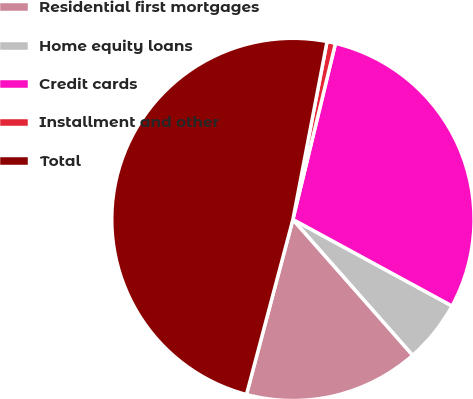<chart> <loc_0><loc_0><loc_500><loc_500><pie_chart><fcel>Residential first mortgages<fcel>Home equity loans<fcel>Credit cards<fcel>Installment and other<fcel>Total<nl><fcel>15.63%<fcel>5.57%<fcel>29.15%<fcel>0.76%<fcel>48.89%<nl></chart> 